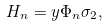<formula> <loc_0><loc_0><loc_500><loc_500>H _ { n } = y \Phi _ { n } \sigma _ { 2 } ,</formula> 